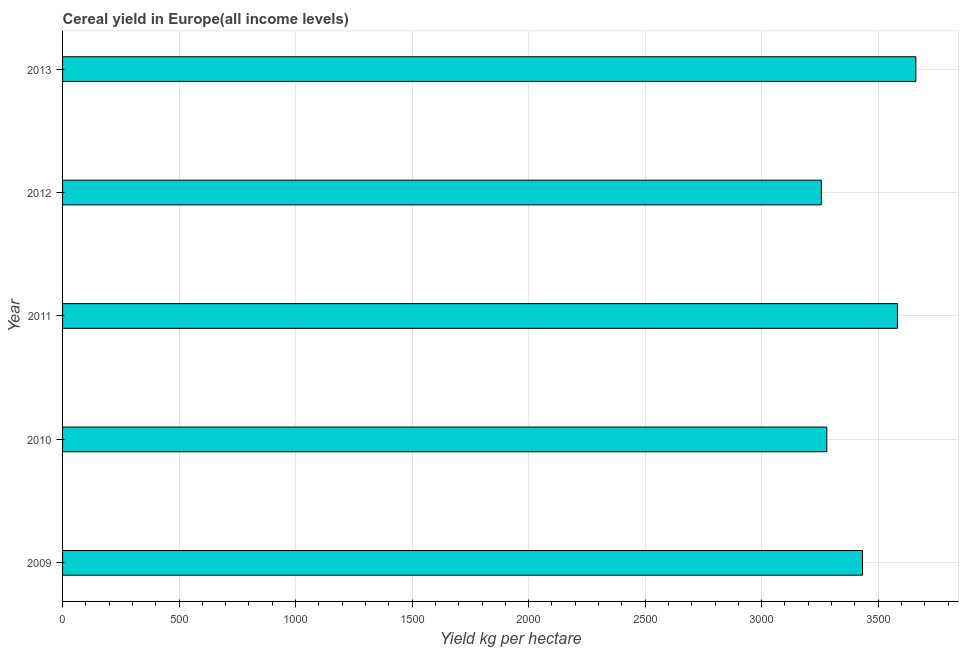Does the graph contain any zero values?
Provide a short and direct response. No. What is the title of the graph?
Offer a terse response. Cereal yield in Europe(all income levels). What is the label or title of the X-axis?
Provide a short and direct response. Yield kg per hectare. What is the cereal yield in 2009?
Your response must be concise. 3432.83. Across all years, what is the maximum cereal yield?
Offer a terse response. 3661.59. Across all years, what is the minimum cereal yield?
Keep it short and to the point. 3256.27. In which year was the cereal yield minimum?
Your answer should be compact. 2012. What is the sum of the cereal yield?
Your answer should be compact. 1.72e+04. What is the difference between the cereal yield in 2010 and 2011?
Your answer should be very brief. -303. What is the average cereal yield per year?
Give a very brief answer. 3442.61. What is the median cereal yield?
Your response must be concise. 3432.83. What is the ratio of the cereal yield in 2009 to that in 2010?
Give a very brief answer. 1.05. Is the difference between the cereal yield in 2009 and 2013 greater than the difference between any two years?
Give a very brief answer. No. What is the difference between the highest and the second highest cereal yield?
Keep it short and to the point. 78.91. What is the difference between the highest and the lowest cereal yield?
Your response must be concise. 405.32. How many bars are there?
Provide a short and direct response. 5. Are all the bars in the graph horizontal?
Your answer should be compact. Yes. How many years are there in the graph?
Give a very brief answer. 5. What is the difference between two consecutive major ticks on the X-axis?
Keep it short and to the point. 500. What is the Yield kg per hectare of 2009?
Your response must be concise. 3432.83. What is the Yield kg per hectare of 2010?
Your answer should be compact. 3279.68. What is the Yield kg per hectare in 2011?
Your response must be concise. 3582.68. What is the Yield kg per hectare in 2012?
Your response must be concise. 3256.27. What is the Yield kg per hectare of 2013?
Provide a short and direct response. 3661.59. What is the difference between the Yield kg per hectare in 2009 and 2010?
Make the answer very short. 153.15. What is the difference between the Yield kg per hectare in 2009 and 2011?
Provide a succinct answer. -149.85. What is the difference between the Yield kg per hectare in 2009 and 2012?
Your answer should be compact. 176.56. What is the difference between the Yield kg per hectare in 2009 and 2013?
Provide a succinct answer. -228.76. What is the difference between the Yield kg per hectare in 2010 and 2011?
Provide a succinct answer. -303. What is the difference between the Yield kg per hectare in 2010 and 2012?
Provide a short and direct response. 23.41. What is the difference between the Yield kg per hectare in 2010 and 2013?
Make the answer very short. -381.92. What is the difference between the Yield kg per hectare in 2011 and 2012?
Give a very brief answer. 326.41. What is the difference between the Yield kg per hectare in 2011 and 2013?
Provide a succinct answer. -78.91. What is the difference between the Yield kg per hectare in 2012 and 2013?
Ensure brevity in your answer.  -405.32. What is the ratio of the Yield kg per hectare in 2009 to that in 2010?
Provide a short and direct response. 1.05. What is the ratio of the Yield kg per hectare in 2009 to that in 2011?
Provide a short and direct response. 0.96. What is the ratio of the Yield kg per hectare in 2009 to that in 2012?
Offer a terse response. 1.05. What is the ratio of the Yield kg per hectare in 2009 to that in 2013?
Keep it short and to the point. 0.94. What is the ratio of the Yield kg per hectare in 2010 to that in 2011?
Make the answer very short. 0.92. What is the ratio of the Yield kg per hectare in 2010 to that in 2013?
Your answer should be very brief. 0.9. What is the ratio of the Yield kg per hectare in 2011 to that in 2013?
Your response must be concise. 0.98. What is the ratio of the Yield kg per hectare in 2012 to that in 2013?
Keep it short and to the point. 0.89. 